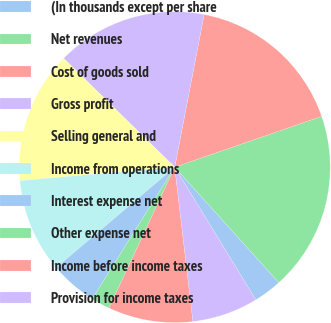<chart> <loc_0><loc_0><loc_500><loc_500><pie_chart><fcel>(In thousands except per share<fcel>Net revenues<fcel>Cost of goods sold<fcel>Gross profit<fcel>Selling general and<fcel>Income from operations<fcel>Interest expense net<fcel>Other expense net<fcel>Income before income taxes<fcel>Provision for income taxes<nl><fcel>2.94%<fcel>18.63%<fcel>16.67%<fcel>15.69%<fcel>13.73%<fcel>9.8%<fcel>4.9%<fcel>1.96%<fcel>8.82%<fcel>6.86%<nl></chart> 